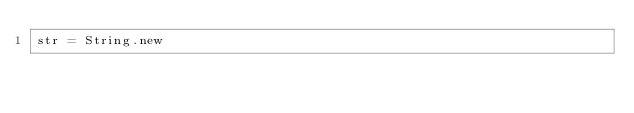<code> <loc_0><loc_0><loc_500><loc_500><_Ruby_>str = String.new
</code> 